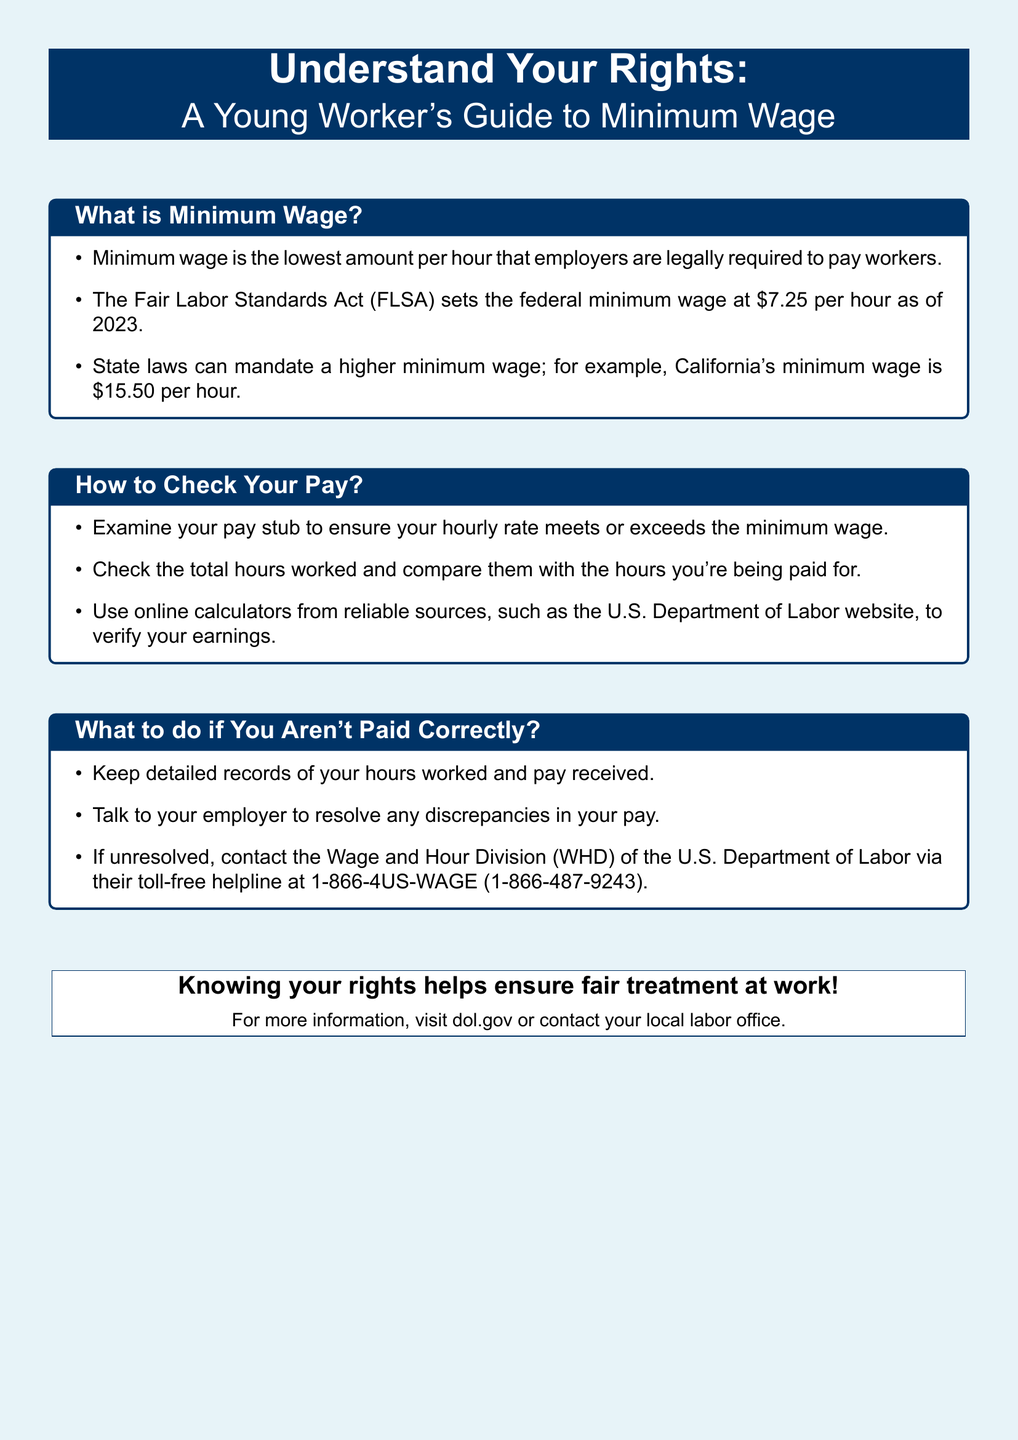What is the federal minimum wage in 2023? The federal minimum wage, as set by the Fair Labor Standards Act, is $7.25 per hour in 2023.
Answer: $7.25 per hour What is California's minimum wage? California's minimum wage is higher than the federal rate at $15.50 per hour.
Answer: $15.50 per hour Where can you check your pay? You can check your pay by examining your pay stub to ensure your hourly rate meets or exceeds minimum wage.
Answer: Pay stub What should you keep records of if you're not paid correctly? It's important to keep detailed records of your hours worked and pay received if you're not paid correctly.
Answer: Hours worked and pay received What should you do if your pay discrepancy is unresolved? If your pay discrepancy is unresolved, you should contact the Wage and Hour Division of the U.S. Department of Labor.
Answer: Contact the Wage and Hour Division What is the toll-free helpline number for the Wage and Hour Division? The toll-free helpline for the Wage and Hour Division is listed as 1-866-4US-WAGE (1-866-487-9243).
Answer: 1-866-4US-WAGE 